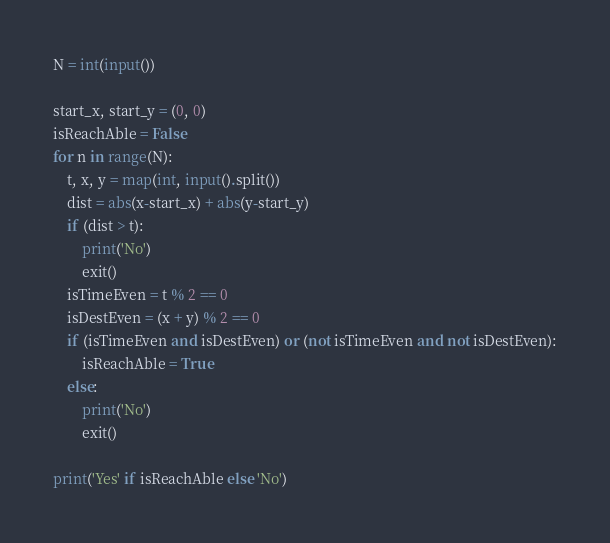<code> <loc_0><loc_0><loc_500><loc_500><_Python_>N = int(input())

start_x, start_y = (0, 0)
isReachAble = False
for n in range(N):
    t, x, y = map(int, input().split())
    dist = abs(x-start_x) + abs(y-start_y)
    if (dist > t):
        print('No')
        exit()
    isTimeEven = t % 2 == 0
    isDestEven = (x + y) % 2 == 0
    if (isTimeEven and isDestEven) or (not isTimeEven and not isDestEven):
        isReachAble = True
    else:
        print('No')
        exit()

print('Yes' if isReachAble else 'No')
</code> 